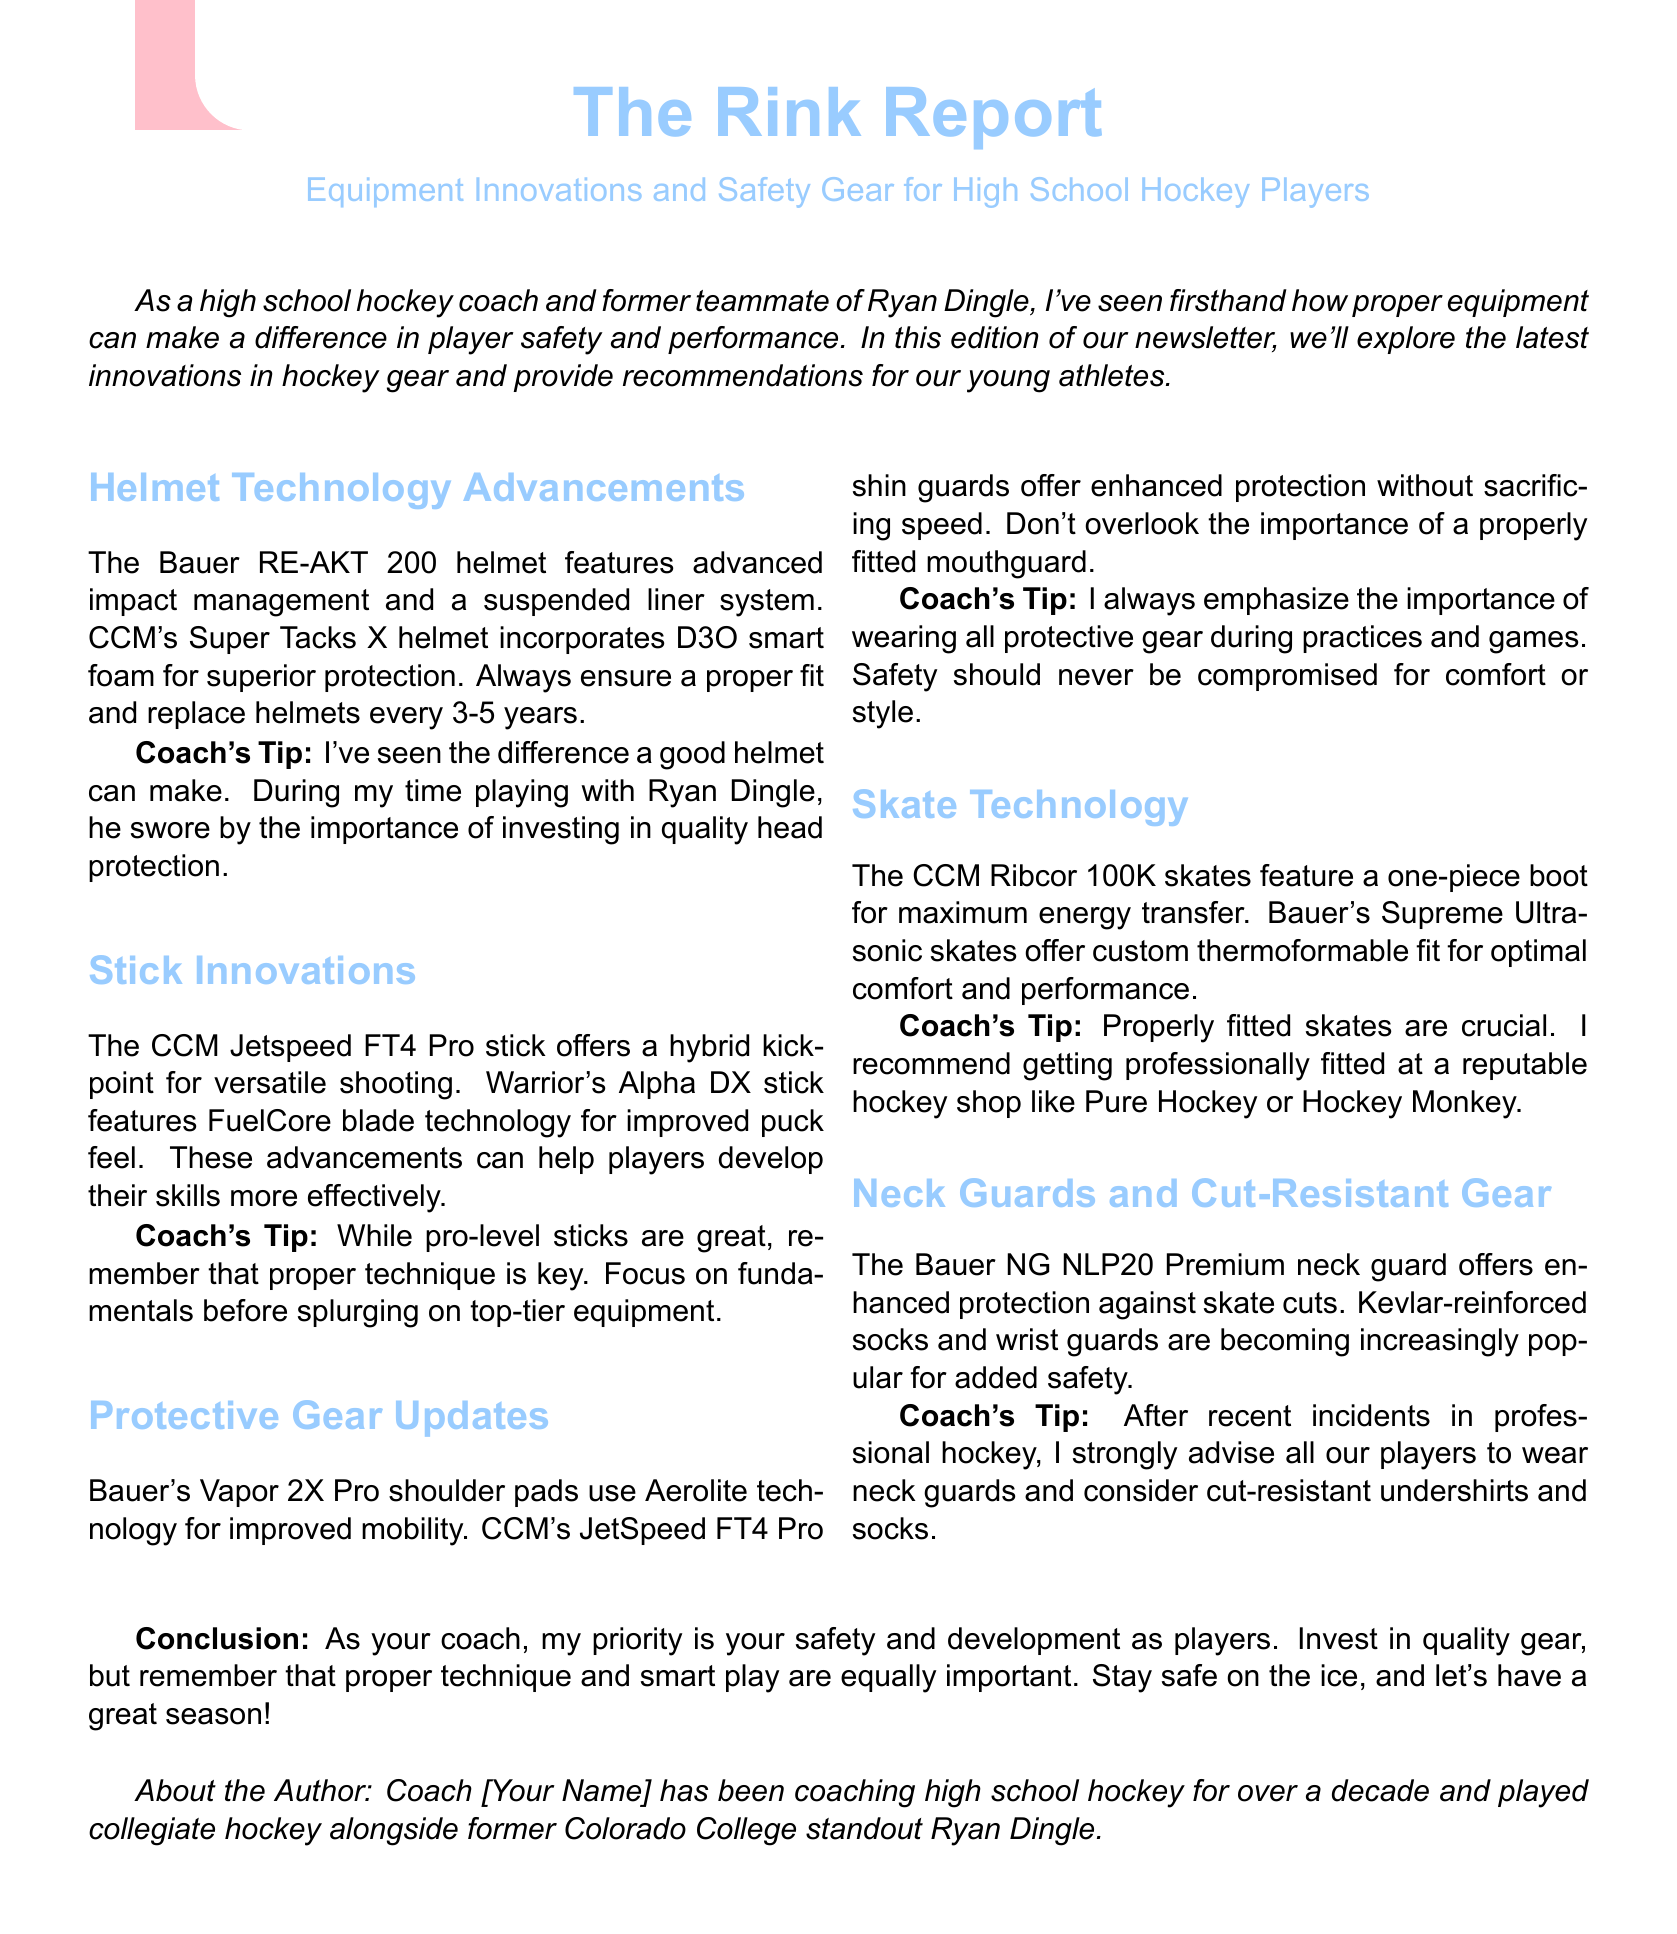what is the title of the newsletter? The title is presented at the beginning of the document.
Answer: The Rink Report: Equipment Innovations and Safety Gear for High School Hockey Players what is the recommended replacement period for helmets? The document states the time frame to replace helmets.
Answer: 3-5 years which helmet incorporates D3O smart foam? This information is found in the helmet technology section regarding specific models.
Answer: CCM's Super Tacks X what technology do Bauer's Vapor 2X Pro shoulder pads use? The technology used is mentioned in the protective gear updates section.
Answer: Aerolite technology what type of kick-point does the CCM Jetspeed FT4 Pro stick feature? The description of the stick's features provides this information.
Answer: hybrid kick-point why does the author emphasize wearing all protective gear? The author mentions this to prioritize safety in practices and games.
Answer: Safety how does the Bauer NG NLP20 Premium neck guard enhance protection? The document highlights the specific type of protection it offers against injuries.
Answer: skate cuts which hockey shop does the coach recommend for professional skate fitting? The recommendation for skate fitting service is listed in the skate technology section.
Answer: Pure Hockey or Hockey Monkey what is the primary purpose of the newsletter? The main reason for the document's existence is stated in the introduction.
Answer: player safety and performance 